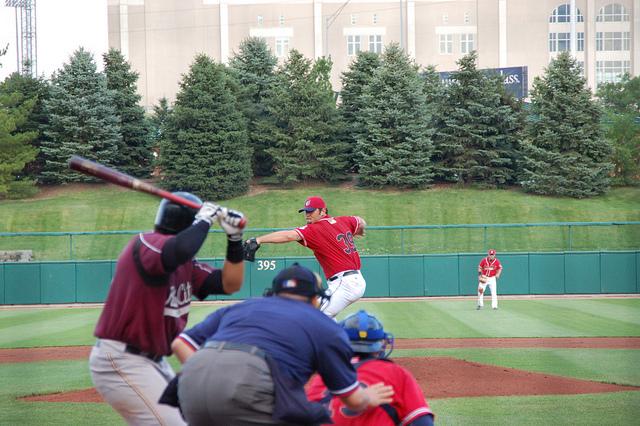Is there something in the umpire's back pocket?
Short answer required. Yes. What game are they playing?
Answer briefly. Baseball. Has the batter swung yet?
Answer briefly. No. 